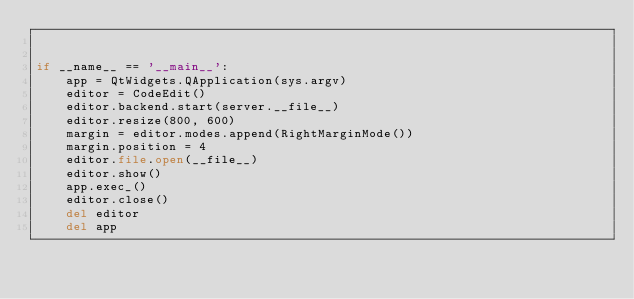Convert code to text. <code><loc_0><loc_0><loc_500><loc_500><_Python_>

if __name__ == '__main__':
    app = QtWidgets.QApplication(sys.argv)
    editor = CodeEdit()
    editor.backend.start(server.__file__)
    editor.resize(800, 600)
    margin = editor.modes.append(RightMarginMode())
    margin.position = 4
    editor.file.open(__file__)
    editor.show()
    app.exec_()
    editor.close()
    del editor
    del app
</code> 